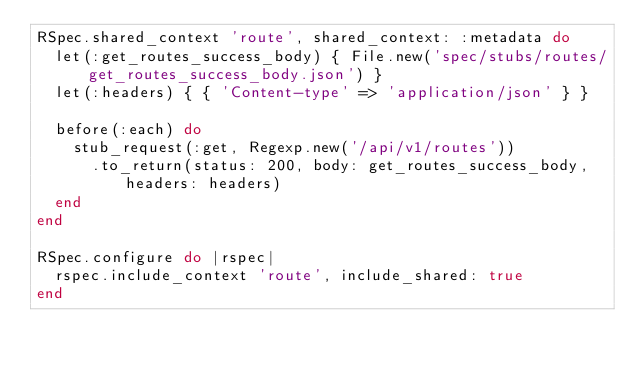<code> <loc_0><loc_0><loc_500><loc_500><_Ruby_>RSpec.shared_context 'route', shared_context: :metadata do
  let(:get_routes_success_body) { File.new('spec/stubs/routes/get_routes_success_body.json') }
  let(:headers) { { 'Content-type' => 'application/json' } }

  before(:each) do
    stub_request(:get, Regexp.new('/api/v1/routes'))
      .to_return(status: 200, body: get_routes_success_body, headers: headers)
  end
end

RSpec.configure do |rspec|
  rspec.include_context 'route', include_shared: true
end
</code> 